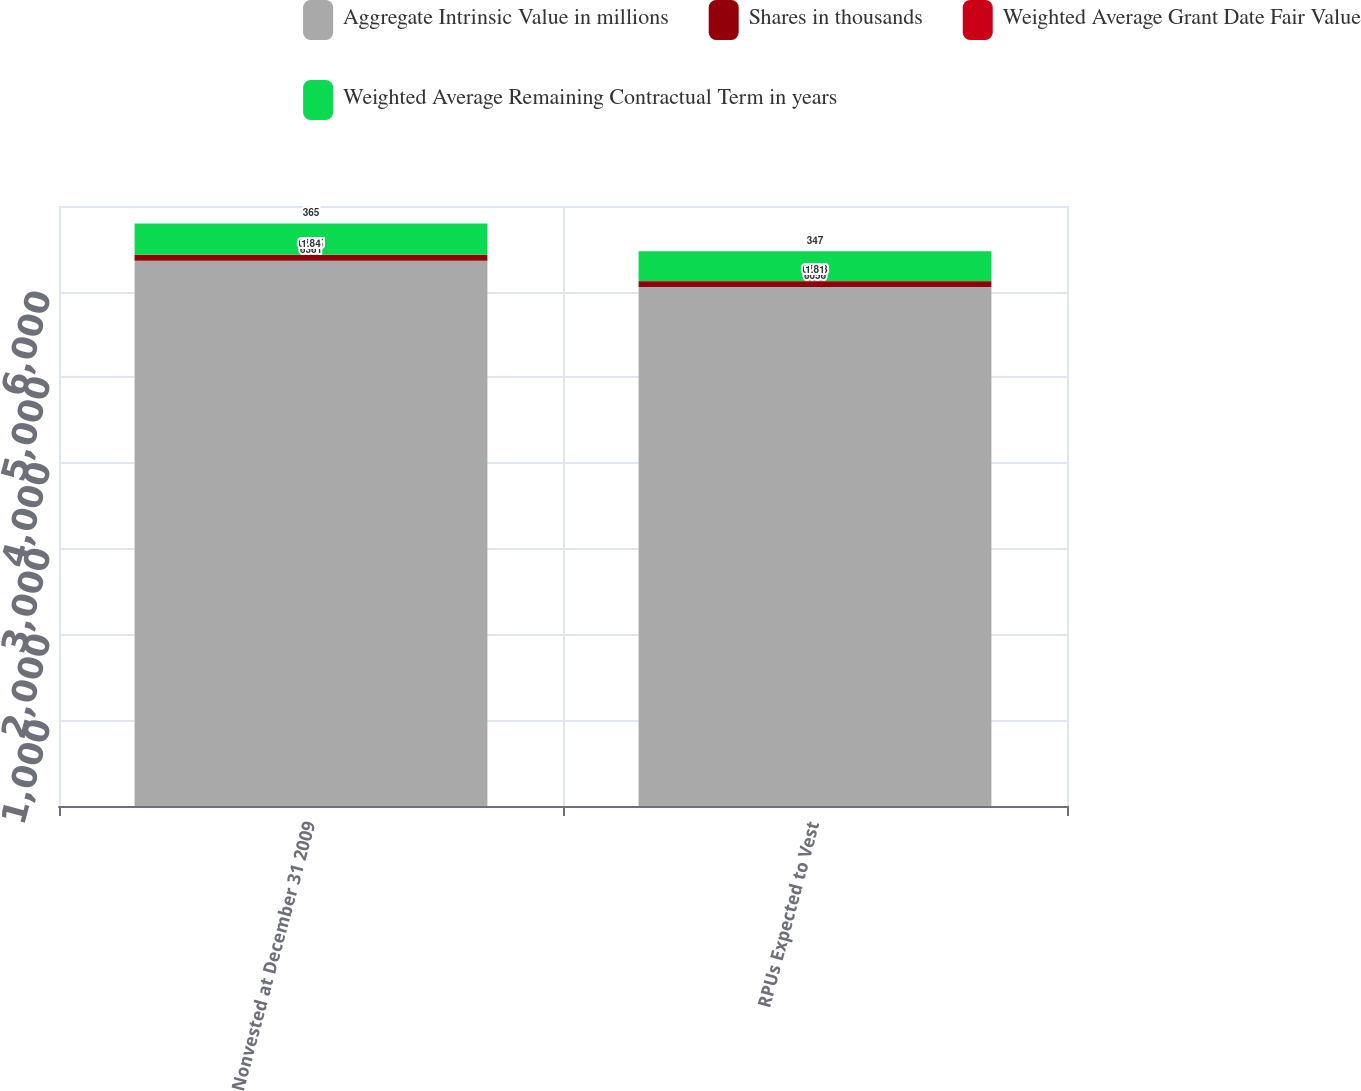<chart> <loc_0><loc_0><loc_500><loc_500><stacked_bar_chart><ecel><fcel>Nonvested at December 31 2009<fcel>RPUs Expected to Vest<nl><fcel>Aggregate Intrinsic Value in millions<fcel>6361<fcel>6056<nl><fcel>Shares in thousands<fcel>67.25<fcel>67.28<nl><fcel>Weighted Average Grant Date Fair Value<fcel>1.84<fcel>1.81<nl><fcel>Weighted Average Remaining Contractual Term in years<fcel>365<fcel>347<nl></chart> 